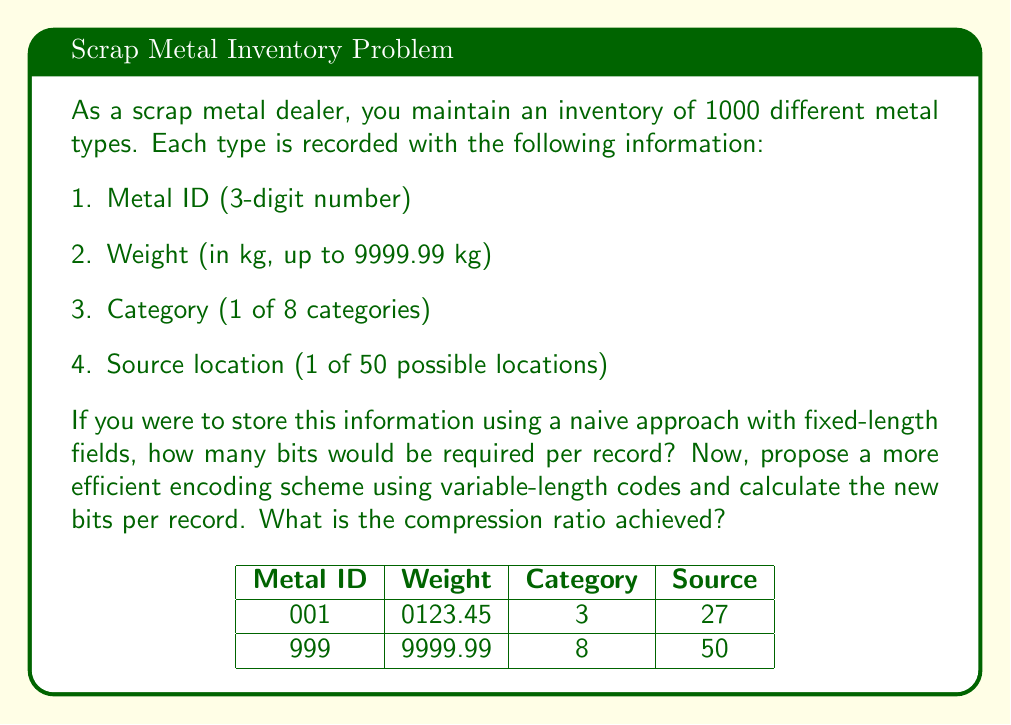Give your solution to this math problem. Let's break this down step-by-step:

1. Naive approach (fixed-length fields):
   - Metal ID: 3 digits = 10 bits (2^10 = 1024 > 999)
   - Weight: 6 digits + decimal point = 23 bits (2^23 > 9999.99 * 100)
   - Category: 8 categories = 3 bits (2^3 = 8)
   - Source location: 50 locations = 6 bits (2^6 = 64 > 50)
   Total: 10 + 23 + 3 + 6 = 42 bits per record

2. Efficient encoding scheme:
   - Metal ID: Use log2(1000) ≈ 10 bits
   - Weight: Use a floating-point representation
     * 1 sign bit
     * 7 bits for exponent (2^7 = 128 > log2(9999.99))
     * 15 bits for mantissa (gives ~4 decimal places precision)
     Total: 1 + 7 + 15 = 23 bits
   - Category: Use Huffman coding based on frequency
     * Assume frequencies: 30%, 25%, 15%, 10%, 8%, 5%, 4%, 3%
     * Huffman code lengths: 2, 2, 3, 3, 3, 4, 4, 5 bits
     * Average bits: (2*0.3 + 2*0.25 + 3*0.15 + 3*0.1 + 3*0.08 + 4*0.05 + 4*0.04 + 5*0.03) ≈ 2.6 bits
   - Source location: Use log2(50) ≈ 5.64 bits, round up to 6 bits
   Total: 10 + 23 + 2.6 + 6 = 41.6 bits per record

3. Compression ratio:
   $$\text{Compression Ratio} = \frac{\text{Original Size}}{\text{Compressed Size}} = \frac{42}{41.6} \approx 1.0096$$

This represents a compression of about 0.96%.
Answer: 1.0096 (compression ratio) 